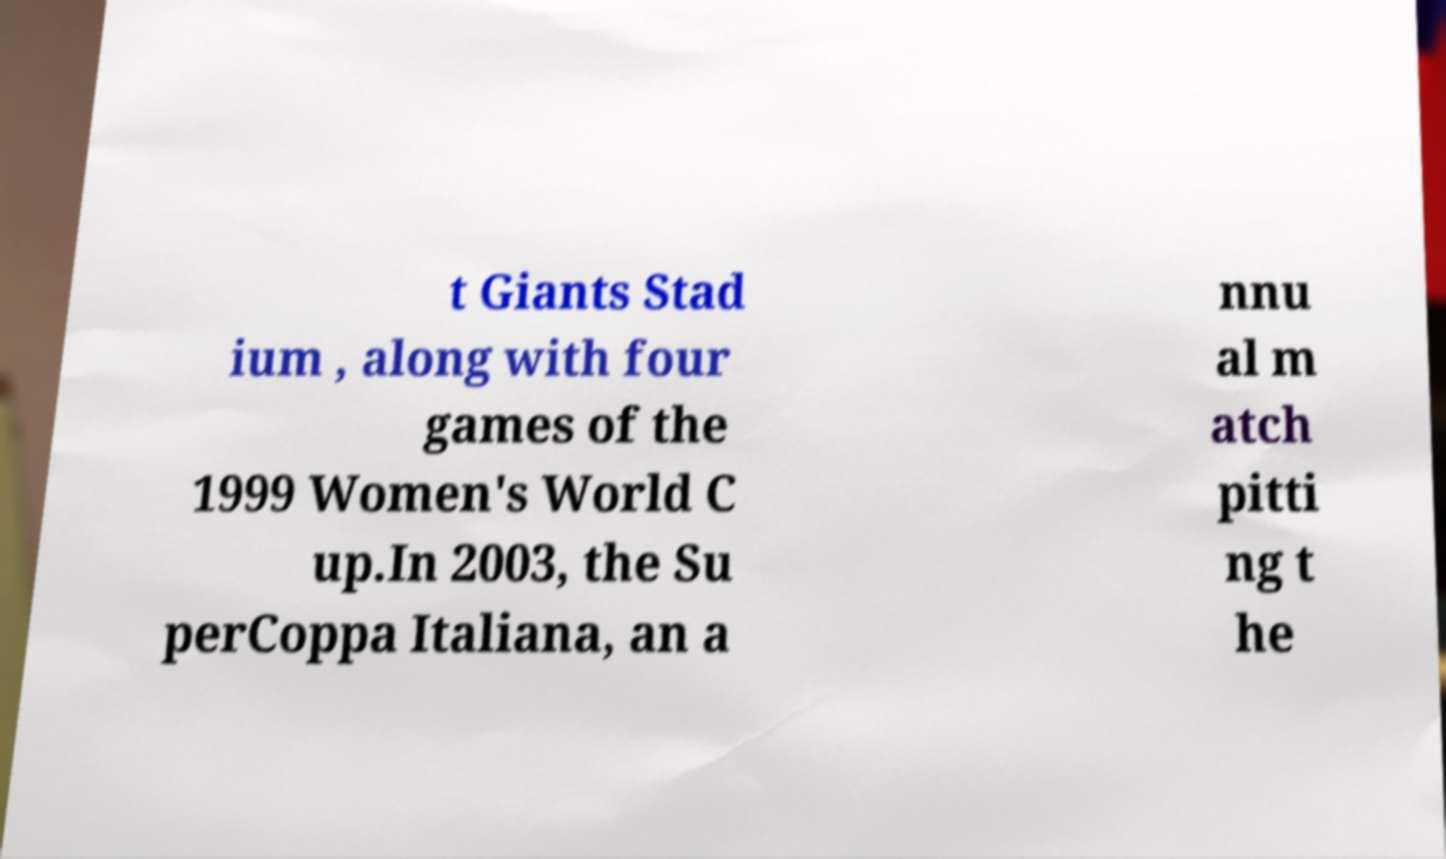I need the written content from this picture converted into text. Can you do that? t Giants Stad ium , along with four games of the 1999 Women's World C up.In 2003, the Su perCoppa Italiana, an a nnu al m atch pitti ng t he 